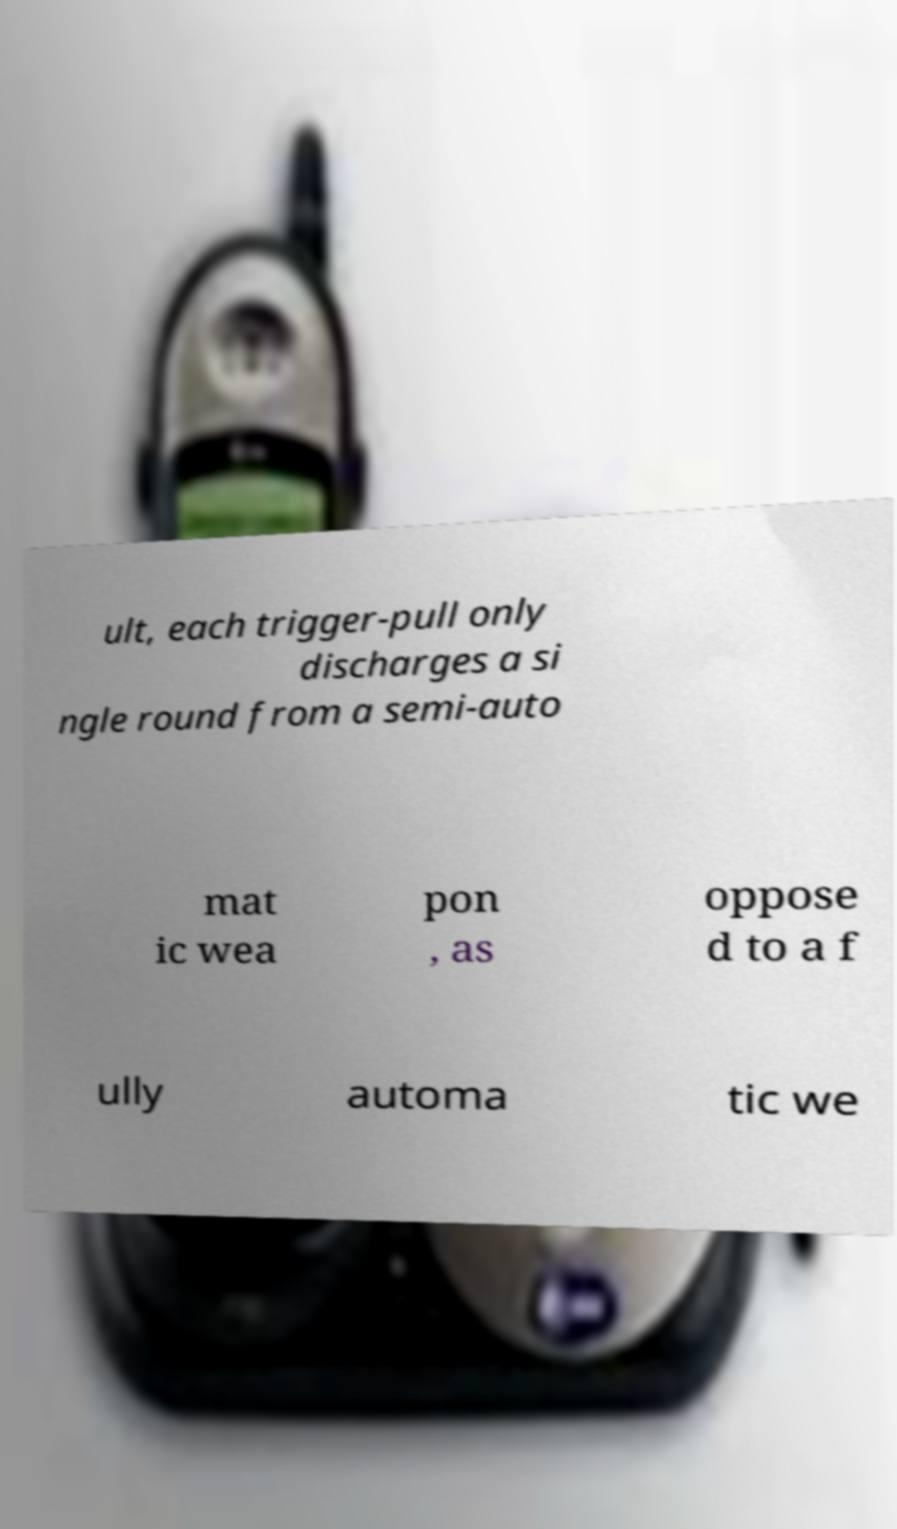What messages or text are displayed in this image? I need them in a readable, typed format. ult, each trigger-pull only discharges a si ngle round from a semi-auto mat ic wea pon , as oppose d to a f ully automa tic we 